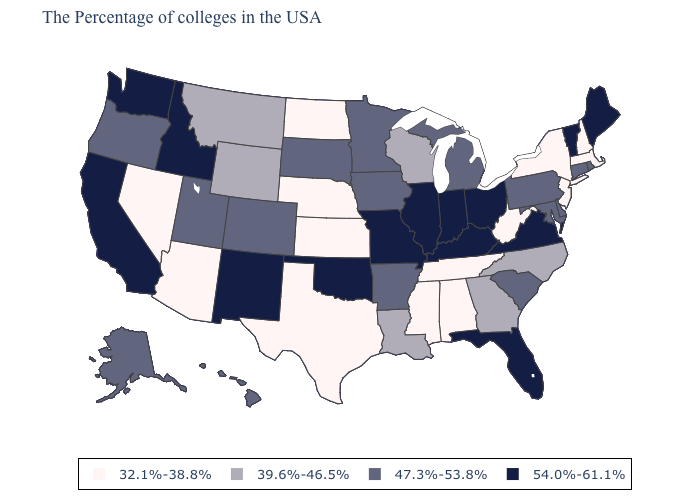Name the states that have a value in the range 54.0%-61.1%?
Keep it brief. Maine, Vermont, Virginia, Ohio, Florida, Kentucky, Indiana, Illinois, Missouri, Oklahoma, New Mexico, Idaho, California, Washington. Among the states that border Indiana , which have the highest value?
Concise answer only. Ohio, Kentucky, Illinois. Name the states that have a value in the range 39.6%-46.5%?
Answer briefly. North Carolina, Georgia, Wisconsin, Louisiana, Wyoming, Montana. Name the states that have a value in the range 54.0%-61.1%?
Keep it brief. Maine, Vermont, Virginia, Ohio, Florida, Kentucky, Indiana, Illinois, Missouri, Oklahoma, New Mexico, Idaho, California, Washington. Name the states that have a value in the range 54.0%-61.1%?
Answer briefly. Maine, Vermont, Virginia, Ohio, Florida, Kentucky, Indiana, Illinois, Missouri, Oklahoma, New Mexico, Idaho, California, Washington. How many symbols are there in the legend?
Quick response, please. 4. What is the highest value in the West ?
Short answer required. 54.0%-61.1%. What is the value of North Dakota?
Keep it brief. 32.1%-38.8%. Does New Mexico have the highest value in the USA?
Short answer required. Yes. How many symbols are there in the legend?
Answer briefly. 4. Among the states that border Utah , which have the lowest value?
Answer briefly. Arizona, Nevada. Name the states that have a value in the range 39.6%-46.5%?
Concise answer only. North Carolina, Georgia, Wisconsin, Louisiana, Wyoming, Montana. Does New Jersey have the lowest value in the USA?
Write a very short answer. Yes. Among the states that border Kentucky , does Missouri have the lowest value?
Be succinct. No. What is the value of Oklahoma?
Keep it brief. 54.0%-61.1%. 